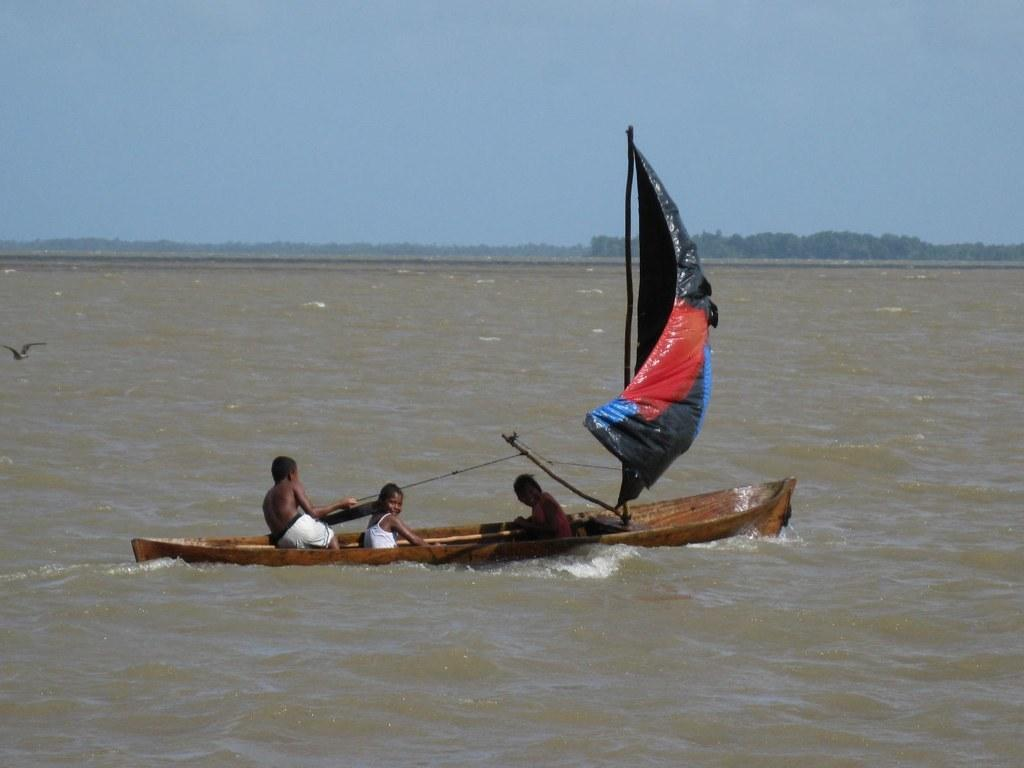What activity are the people in the image engaged in? The people in the image are sailing a boat. Where is the boat located? The boat is on the water. What can be seen on the left side of the image? There is a bird flying on the left side of the image. What is visible in the background of the image? There are trees and the sky visible in the background of the image. What type of queen is sitting on the boat in the image? There is no queen present in the image; it features people sailing a boat. How many cents are visible on the boat in the image? There are no cents present in the image; it features a boat on the water. 